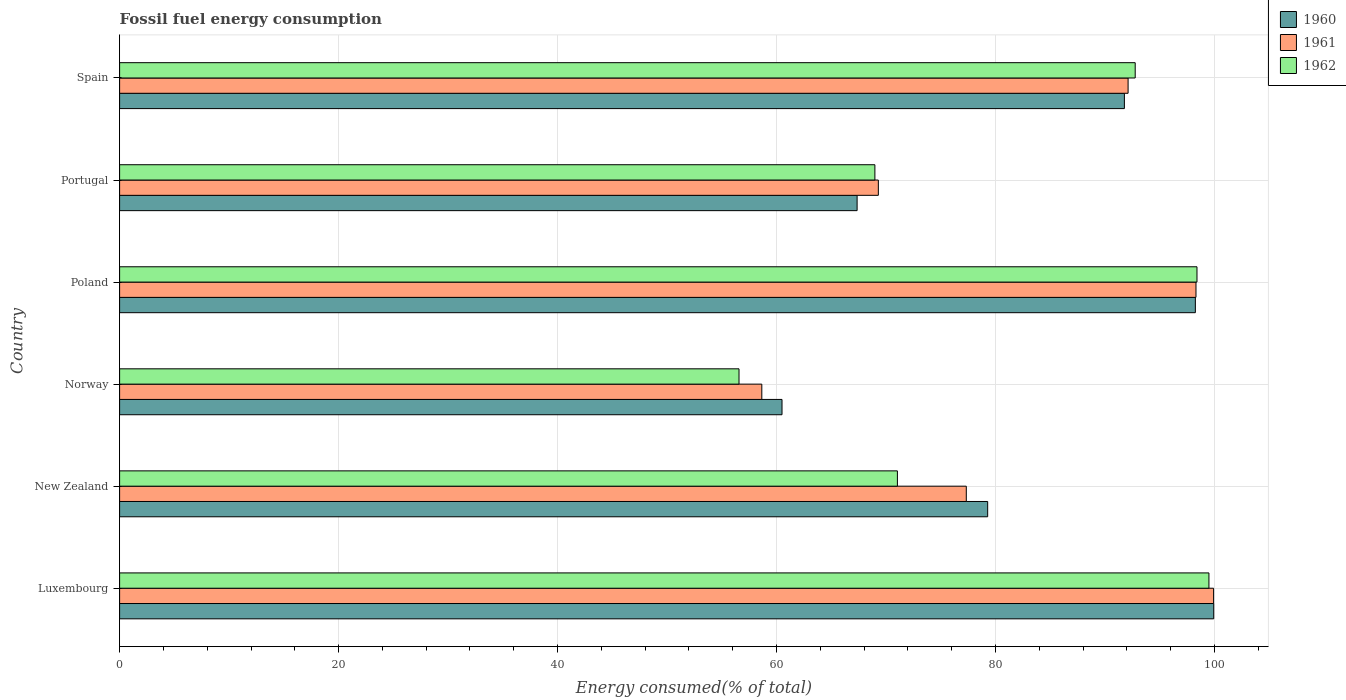How many groups of bars are there?
Give a very brief answer. 6. Are the number of bars per tick equal to the number of legend labels?
Your response must be concise. Yes. Are the number of bars on each tick of the Y-axis equal?
Give a very brief answer. Yes. How many bars are there on the 2nd tick from the top?
Your answer should be compact. 3. How many bars are there on the 3rd tick from the bottom?
Your response must be concise. 3. What is the label of the 6th group of bars from the top?
Offer a very short reply. Luxembourg. In how many cases, is the number of bars for a given country not equal to the number of legend labels?
Your response must be concise. 0. What is the percentage of energy consumed in 1962 in Poland?
Keep it short and to the point. 98.4. Across all countries, what is the maximum percentage of energy consumed in 1962?
Your answer should be compact. 99.49. Across all countries, what is the minimum percentage of energy consumed in 1961?
Your answer should be very brief. 58.65. In which country was the percentage of energy consumed in 1962 maximum?
Provide a short and direct response. Luxembourg. In which country was the percentage of energy consumed in 1962 minimum?
Offer a very short reply. Norway. What is the total percentage of energy consumed in 1961 in the graph?
Offer a very short reply. 495.6. What is the difference between the percentage of energy consumed in 1960 in Luxembourg and that in Poland?
Your answer should be compact. 1.68. What is the difference between the percentage of energy consumed in 1962 in Poland and the percentage of energy consumed in 1960 in New Zealand?
Give a very brief answer. 19.12. What is the average percentage of energy consumed in 1960 per country?
Your answer should be very brief. 82.84. What is the difference between the percentage of energy consumed in 1960 and percentage of energy consumed in 1961 in Norway?
Your answer should be very brief. 1.85. What is the ratio of the percentage of energy consumed in 1962 in New Zealand to that in Portugal?
Provide a succinct answer. 1.03. Is the percentage of energy consumed in 1961 in Luxembourg less than that in Spain?
Make the answer very short. No. What is the difference between the highest and the second highest percentage of energy consumed in 1961?
Offer a very short reply. 1.61. What is the difference between the highest and the lowest percentage of energy consumed in 1961?
Keep it short and to the point. 41.26. In how many countries, is the percentage of energy consumed in 1962 greater than the average percentage of energy consumed in 1962 taken over all countries?
Make the answer very short. 3. Is it the case that in every country, the sum of the percentage of energy consumed in 1962 and percentage of energy consumed in 1960 is greater than the percentage of energy consumed in 1961?
Keep it short and to the point. Yes. Are all the bars in the graph horizontal?
Give a very brief answer. Yes. How many countries are there in the graph?
Give a very brief answer. 6. Does the graph contain any zero values?
Make the answer very short. No. Does the graph contain grids?
Ensure brevity in your answer.  Yes. How many legend labels are there?
Your response must be concise. 3. How are the legend labels stacked?
Ensure brevity in your answer.  Vertical. What is the title of the graph?
Give a very brief answer. Fossil fuel energy consumption. What is the label or title of the X-axis?
Your answer should be compact. Energy consumed(% of total). What is the label or title of the Y-axis?
Your answer should be very brief. Country. What is the Energy consumed(% of total) of 1960 in Luxembourg?
Your answer should be compact. 99.92. What is the Energy consumed(% of total) in 1961 in Luxembourg?
Give a very brief answer. 99.91. What is the Energy consumed(% of total) of 1962 in Luxembourg?
Ensure brevity in your answer.  99.49. What is the Energy consumed(% of total) in 1960 in New Zealand?
Ensure brevity in your answer.  79.28. What is the Energy consumed(% of total) in 1961 in New Zealand?
Ensure brevity in your answer.  77.33. What is the Energy consumed(% of total) in 1962 in New Zealand?
Provide a short and direct response. 71.04. What is the Energy consumed(% of total) of 1960 in Norway?
Provide a succinct answer. 60.5. What is the Energy consumed(% of total) in 1961 in Norway?
Offer a very short reply. 58.65. What is the Energy consumed(% of total) of 1962 in Norway?
Make the answer very short. 56.57. What is the Energy consumed(% of total) in 1960 in Poland?
Your answer should be compact. 98.25. What is the Energy consumed(% of total) in 1961 in Poland?
Offer a terse response. 98.3. What is the Energy consumed(% of total) of 1962 in Poland?
Offer a very short reply. 98.4. What is the Energy consumed(% of total) in 1960 in Portugal?
Make the answer very short. 67.36. What is the Energy consumed(% of total) of 1961 in Portugal?
Offer a terse response. 69.3. What is the Energy consumed(% of total) in 1962 in Portugal?
Your answer should be compact. 68.98. What is the Energy consumed(% of total) in 1960 in Spain?
Provide a succinct answer. 91.77. What is the Energy consumed(% of total) in 1961 in Spain?
Make the answer very short. 92.1. What is the Energy consumed(% of total) in 1962 in Spain?
Give a very brief answer. 92.75. Across all countries, what is the maximum Energy consumed(% of total) in 1960?
Ensure brevity in your answer.  99.92. Across all countries, what is the maximum Energy consumed(% of total) in 1961?
Your answer should be very brief. 99.91. Across all countries, what is the maximum Energy consumed(% of total) of 1962?
Your answer should be very brief. 99.49. Across all countries, what is the minimum Energy consumed(% of total) of 1960?
Offer a very short reply. 60.5. Across all countries, what is the minimum Energy consumed(% of total) in 1961?
Offer a terse response. 58.65. Across all countries, what is the minimum Energy consumed(% of total) of 1962?
Offer a terse response. 56.57. What is the total Energy consumed(% of total) in 1960 in the graph?
Offer a terse response. 497.07. What is the total Energy consumed(% of total) of 1961 in the graph?
Provide a succinct answer. 495.6. What is the total Energy consumed(% of total) in 1962 in the graph?
Provide a succinct answer. 487.22. What is the difference between the Energy consumed(% of total) of 1960 in Luxembourg and that in New Zealand?
Your answer should be compact. 20.65. What is the difference between the Energy consumed(% of total) in 1961 in Luxembourg and that in New Zealand?
Make the answer very short. 22.58. What is the difference between the Energy consumed(% of total) of 1962 in Luxembourg and that in New Zealand?
Offer a very short reply. 28.45. What is the difference between the Energy consumed(% of total) in 1960 in Luxembourg and that in Norway?
Provide a succinct answer. 39.43. What is the difference between the Energy consumed(% of total) of 1961 in Luxembourg and that in Norway?
Provide a succinct answer. 41.26. What is the difference between the Energy consumed(% of total) in 1962 in Luxembourg and that in Norway?
Your response must be concise. 42.92. What is the difference between the Energy consumed(% of total) of 1960 in Luxembourg and that in Poland?
Keep it short and to the point. 1.68. What is the difference between the Energy consumed(% of total) of 1961 in Luxembourg and that in Poland?
Provide a short and direct response. 1.61. What is the difference between the Energy consumed(% of total) of 1962 in Luxembourg and that in Poland?
Give a very brief answer. 1.09. What is the difference between the Energy consumed(% of total) of 1960 in Luxembourg and that in Portugal?
Provide a short and direct response. 32.57. What is the difference between the Energy consumed(% of total) in 1961 in Luxembourg and that in Portugal?
Ensure brevity in your answer.  30.62. What is the difference between the Energy consumed(% of total) of 1962 in Luxembourg and that in Portugal?
Offer a very short reply. 30.51. What is the difference between the Energy consumed(% of total) of 1960 in Luxembourg and that in Spain?
Provide a short and direct response. 8.16. What is the difference between the Energy consumed(% of total) of 1961 in Luxembourg and that in Spain?
Your answer should be very brief. 7.81. What is the difference between the Energy consumed(% of total) of 1962 in Luxembourg and that in Spain?
Provide a succinct answer. 6.73. What is the difference between the Energy consumed(% of total) of 1960 in New Zealand and that in Norway?
Make the answer very short. 18.78. What is the difference between the Energy consumed(% of total) in 1961 in New Zealand and that in Norway?
Give a very brief answer. 18.68. What is the difference between the Energy consumed(% of total) of 1962 in New Zealand and that in Norway?
Make the answer very short. 14.47. What is the difference between the Energy consumed(% of total) in 1960 in New Zealand and that in Poland?
Make the answer very short. -18.97. What is the difference between the Energy consumed(% of total) in 1961 in New Zealand and that in Poland?
Offer a very short reply. -20.98. What is the difference between the Energy consumed(% of total) of 1962 in New Zealand and that in Poland?
Your response must be concise. -27.36. What is the difference between the Energy consumed(% of total) in 1960 in New Zealand and that in Portugal?
Offer a very short reply. 11.92. What is the difference between the Energy consumed(% of total) in 1961 in New Zealand and that in Portugal?
Your answer should be compact. 8.03. What is the difference between the Energy consumed(% of total) in 1962 in New Zealand and that in Portugal?
Ensure brevity in your answer.  2.06. What is the difference between the Energy consumed(% of total) of 1960 in New Zealand and that in Spain?
Offer a very short reply. -12.49. What is the difference between the Energy consumed(% of total) in 1961 in New Zealand and that in Spain?
Give a very brief answer. -14.78. What is the difference between the Energy consumed(% of total) of 1962 in New Zealand and that in Spain?
Provide a short and direct response. -21.72. What is the difference between the Energy consumed(% of total) of 1960 in Norway and that in Poland?
Your answer should be compact. -37.75. What is the difference between the Energy consumed(% of total) of 1961 in Norway and that in Poland?
Your response must be concise. -39.65. What is the difference between the Energy consumed(% of total) in 1962 in Norway and that in Poland?
Your response must be concise. -41.83. What is the difference between the Energy consumed(% of total) in 1960 in Norway and that in Portugal?
Provide a short and direct response. -6.86. What is the difference between the Energy consumed(% of total) of 1961 in Norway and that in Portugal?
Your response must be concise. -10.64. What is the difference between the Energy consumed(% of total) of 1962 in Norway and that in Portugal?
Your answer should be compact. -12.41. What is the difference between the Energy consumed(% of total) of 1960 in Norway and that in Spain?
Keep it short and to the point. -31.27. What is the difference between the Energy consumed(% of total) of 1961 in Norway and that in Spain?
Ensure brevity in your answer.  -33.45. What is the difference between the Energy consumed(% of total) in 1962 in Norway and that in Spain?
Your answer should be very brief. -36.18. What is the difference between the Energy consumed(% of total) of 1960 in Poland and that in Portugal?
Your answer should be compact. 30.89. What is the difference between the Energy consumed(% of total) in 1961 in Poland and that in Portugal?
Give a very brief answer. 29.01. What is the difference between the Energy consumed(% of total) in 1962 in Poland and that in Portugal?
Give a very brief answer. 29.42. What is the difference between the Energy consumed(% of total) in 1960 in Poland and that in Spain?
Your response must be concise. 6.48. What is the difference between the Energy consumed(% of total) of 1961 in Poland and that in Spain?
Provide a succinct answer. 6.2. What is the difference between the Energy consumed(% of total) in 1962 in Poland and that in Spain?
Ensure brevity in your answer.  5.64. What is the difference between the Energy consumed(% of total) of 1960 in Portugal and that in Spain?
Give a very brief answer. -24.41. What is the difference between the Energy consumed(% of total) of 1961 in Portugal and that in Spain?
Make the answer very short. -22.81. What is the difference between the Energy consumed(% of total) in 1962 in Portugal and that in Spain?
Offer a terse response. -23.77. What is the difference between the Energy consumed(% of total) in 1960 in Luxembourg and the Energy consumed(% of total) in 1961 in New Zealand?
Keep it short and to the point. 22.6. What is the difference between the Energy consumed(% of total) of 1960 in Luxembourg and the Energy consumed(% of total) of 1962 in New Zealand?
Your answer should be very brief. 28.89. What is the difference between the Energy consumed(% of total) in 1961 in Luxembourg and the Energy consumed(% of total) in 1962 in New Zealand?
Provide a short and direct response. 28.88. What is the difference between the Energy consumed(% of total) of 1960 in Luxembourg and the Energy consumed(% of total) of 1961 in Norway?
Your response must be concise. 41.27. What is the difference between the Energy consumed(% of total) of 1960 in Luxembourg and the Energy consumed(% of total) of 1962 in Norway?
Give a very brief answer. 43.35. What is the difference between the Energy consumed(% of total) of 1961 in Luxembourg and the Energy consumed(% of total) of 1962 in Norway?
Your answer should be very brief. 43.34. What is the difference between the Energy consumed(% of total) in 1960 in Luxembourg and the Energy consumed(% of total) in 1961 in Poland?
Offer a terse response. 1.62. What is the difference between the Energy consumed(% of total) in 1960 in Luxembourg and the Energy consumed(% of total) in 1962 in Poland?
Make the answer very short. 1.53. What is the difference between the Energy consumed(% of total) in 1961 in Luxembourg and the Energy consumed(% of total) in 1962 in Poland?
Make the answer very short. 1.52. What is the difference between the Energy consumed(% of total) in 1960 in Luxembourg and the Energy consumed(% of total) in 1961 in Portugal?
Provide a succinct answer. 30.63. What is the difference between the Energy consumed(% of total) of 1960 in Luxembourg and the Energy consumed(% of total) of 1962 in Portugal?
Offer a very short reply. 30.95. What is the difference between the Energy consumed(% of total) in 1961 in Luxembourg and the Energy consumed(% of total) in 1962 in Portugal?
Offer a terse response. 30.93. What is the difference between the Energy consumed(% of total) in 1960 in Luxembourg and the Energy consumed(% of total) in 1961 in Spain?
Keep it short and to the point. 7.82. What is the difference between the Energy consumed(% of total) in 1960 in Luxembourg and the Energy consumed(% of total) in 1962 in Spain?
Make the answer very short. 7.17. What is the difference between the Energy consumed(% of total) of 1961 in Luxembourg and the Energy consumed(% of total) of 1962 in Spain?
Provide a succinct answer. 7.16. What is the difference between the Energy consumed(% of total) of 1960 in New Zealand and the Energy consumed(% of total) of 1961 in Norway?
Provide a succinct answer. 20.63. What is the difference between the Energy consumed(% of total) of 1960 in New Zealand and the Energy consumed(% of total) of 1962 in Norway?
Your response must be concise. 22.71. What is the difference between the Energy consumed(% of total) in 1961 in New Zealand and the Energy consumed(% of total) in 1962 in Norway?
Keep it short and to the point. 20.76. What is the difference between the Energy consumed(% of total) in 1960 in New Zealand and the Energy consumed(% of total) in 1961 in Poland?
Your response must be concise. -19.02. What is the difference between the Energy consumed(% of total) of 1960 in New Zealand and the Energy consumed(% of total) of 1962 in Poland?
Offer a very short reply. -19.12. What is the difference between the Energy consumed(% of total) of 1961 in New Zealand and the Energy consumed(% of total) of 1962 in Poland?
Keep it short and to the point. -21.07. What is the difference between the Energy consumed(% of total) in 1960 in New Zealand and the Energy consumed(% of total) in 1961 in Portugal?
Offer a very short reply. 9.98. What is the difference between the Energy consumed(% of total) in 1960 in New Zealand and the Energy consumed(% of total) in 1962 in Portugal?
Provide a short and direct response. 10.3. What is the difference between the Energy consumed(% of total) of 1961 in New Zealand and the Energy consumed(% of total) of 1962 in Portugal?
Your answer should be very brief. 8.35. What is the difference between the Energy consumed(% of total) of 1960 in New Zealand and the Energy consumed(% of total) of 1961 in Spain?
Give a very brief answer. -12.83. What is the difference between the Energy consumed(% of total) in 1960 in New Zealand and the Energy consumed(% of total) in 1962 in Spain?
Offer a very short reply. -13.47. What is the difference between the Energy consumed(% of total) of 1961 in New Zealand and the Energy consumed(% of total) of 1962 in Spain?
Provide a succinct answer. -15.43. What is the difference between the Energy consumed(% of total) in 1960 in Norway and the Energy consumed(% of total) in 1961 in Poland?
Ensure brevity in your answer.  -37.81. What is the difference between the Energy consumed(% of total) in 1960 in Norway and the Energy consumed(% of total) in 1962 in Poland?
Provide a short and direct response. -37.9. What is the difference between the Energy consumed(% of total) in 1961 in Norway and the Energy consumed(% of total) in 1962 in Poland?
Offer a terse response. -39.74. What is the difference between the Energy consumed(% of total) in 1960 in Norway and the Energy consumed(% of total) in 1961 in Portugal?
Provide a succinct answer. -8.8. What is the difference between the Energy consumed(% of total) in 1960 in Norway and the Energy consumed(% of total) in 1962 in Portugal?
Make the answer very short. -8.48. What is the difference between the Energy consumed(% of total) of 1961 in Norway and the Energy consumed(% of total) of 1962 in Portugal?
Offer a terse response. -10.33. What is the difference between the Energy consumed(% of total) of 1960 in Norway and the Energy consumed(% of total) of 1961 in Spain?
Provide a succinct answer. -31.61. What is the difference between the Energy consumed(% of total) in 1960 in Norway and the Energy consumed(% of total) in 1962 in Spain?
Make the answer very short. -32.26. What is the difference between the Energy consumed(% of total) of 1961 in Norway and the Energy consumed(% of total) of 1962 in Spain?
Keep it short and to the point. -34.1. What is the difference between the Energy consumed(% of total) of 1960 in Poland and the Energy consumed(% of total) of 1961 in Portugal?
Keep it short and to the point. 28.95. What is the difference between the Energy consumed(% of total) in 1960 in Poland and the Energy consumed(% of total) in 1962 in Portugal?
Give a very brief answer. 29.27. What is the difference between the Energy consumed(% of total) in 1961 in Poland and the Energy consumed(% of total) in 1962 in Portugal?
Give a very brief answer. 29.32. What is the difference between the Energy consumed(% of total) in 1960 in Poland and the Energy consumed(% of total) in 1961 in Spain?
Provide a short and direct response. 6.14. What is the difference between the Energy consumed(% of total) in 1960 in Poland and the Energy consumed(% of total) in 1962 in Spain?
Keep it short and to the point. 5.49. What is the difference between the Energy consumed(% of total) in 1961 in Poland and the Energy consumed(% of total) in 1962 in Spain?
Give a very brief answer. 5.55. What is the difference between the Energy consumed(% of total) in 1960 in Portugal and the Energy consumed(% of total) in 1961 in Spain?
Your answer should be compact. -24.75. What is the difference between the Energy consumed(% of total) of 1960 in Portugal and the Energy consumed(% of total) of 1962 in Spain?
Your answer should be compact. -25.4. What is the difference between the Energy consumed(% of total) in 1961 in Portugal and the Energy consumed(% of total) in 1962 in Spain?
Offer a very short reply. -23.46. What is the average Energy consumed(% of total) of 1960 per country?
Ensure brevity in your answer.  82.84. What is the average Energy consumed(% of total) of 1961 per country?
Provide a succinct answer. 82.6. What is the average Energy consumed(% of total) of 1962 per country?
Offer a terse response. 81.2. What is the difference between the Energy consumed(% of total) of 1960 and Energy consumed(% of total) of 1961 in Luxembourg?
Offer a very short reply. 0.01. What is the difference between the Energy consumed(% of total) of 1960 and Energy consumed(% of total) of 1962 in Luxembourg?
Your answer should be compact. 0.44. What is the difference between the Energy consumed(% of total) in 1961 and Energy consumed(% of total) in 1962 in Luxembourg?
Your response must be concise. 0.42. What is the difference between the Energy consumed(% of total) in 1960 and Energy consumed(% of total) in 1961 in New Zealand?
Offer a terse response. 1.95. What is the difference between the Energy consumed(% of total) of 1960 and Energy consumed(% of total) of 1962 in New Zealand?
Give a very brief answer. 8.24. What is the difference between the Energy consumed(% of total) of 1961 and Energy consumed(% of total) of 1962 in New Zealand?
Ensure brevity in your answer.  6.29. What is the difference between the Energy consumed(% of total) in 1960 and Energy consumed(% of total) in 1961 in Norway?
Make the answer very short. 1.85. What is the difference between the Energy consumed(% of total) in 1960 and Energy consumed(% of total) in 1962 in Norway?
Your answer should be very brief. 3.93. What is the difference between the Energy consumed(% of total) of 1961 and Energy consumed(% of total) of 1962 in Norway?
Provide a succinct answer. 2.08. What is the difference between the Energy consumed(% of total) in 1960 and Energy consumed(% of total) in 1961 in Poland?
Give a very brief answer. -0.06. What is the difference between the Energy consumed(% of total) in 1960 and Energy consumed(% of total) in 1962 in Poland?
Your answer should be very brief. -0.15. What is the difference between the Energy consumed(% of total) in 1961 and Energy consumed(% of total) in 1962 in Poland?
Ensure brevity in your answer.  -0.09. What is the difference between the Energy consumed(% of total) in 1960 and Energy consumed(% of total) in 1961 in Portugal?
Keep it short and to the point. -1.94. What is the difference between the Energy consumed(% of total) in 1960 and Energy consumed(% of total) in 1962 in Portugal?
Your answer should be compact. -1.62. What is the difference between the Energy consumed(% of total) in 1961 and Energy consumed(% of total) in 1962 in Portugal?
Keep it short and to the point. 0.32. What is the difference between the Energy consumed(% of total) in 1960 and Energy consumed(% of total) in 1961 in Spain?
Make the answer very short. -0.34. What is the difference between the Energy consumed(% of total) in 1960 and Energy consumed(% of total) in 1962 in Spain?
Keep it short and to the point. -0.99. What is the difference between the Energy consumed(% of total) in 1961 and Energy consumed(% of total) in 1962 in Spain?
Make the answer very short. -0.65. What is the ratio of the Energy consumed(% of total) in 1960 in Luxembourg to that in New Zealand?
Make the answer very short. 1.26. What is the ratio of the Energy consumed(% of total) of 1961 in Luxembourg to that in New Zealand?
Ensure brevity in your answer.  1.29. What is the ratio of the Energy consumed(% of total) in 1962 in Luxembourg to that in New Zealand?
Give a very brief answer. 1.4. What is the ratio of the Energy consumed(% of total) in 1960 in Luxembourg to that in Norway?
Your response must be concise. 1.65. What is the ratio of the Energy consumed(% of total) of 1961 in Luxembourg to that in Norway?
Ensure brevity in your answer.  1.7. What is the ratio of the Energy consumed(% of total) in 1962 in Luxembourg to that in Norway?
Your answer should be very brief. 1.76. What is the ratio of the Energy consumed(% of total) of 1960 in Luxembourg to that in Poland?
Keep it short and to the point. 1.02. What is the ratio of the Energy consumed(% of total) in 1961 in Luxembourg to that in Poland?
Offer a terse response. 1.02. What is the ratio of the Energy consumed(% of total) in 1962 in Luxembourg to that in Poland?
Offer a terse response. 1.01. What is the ratio of the Energy consumed(% of total) in 1960 in Luxembourg to that in Portugal?
Your answer should be very brief. 1.48. What is the ratio of the Energy consumed(% of total) in 1961 in Luxembourg to that in Portugal?
Your answer should be very brief. 1.44. What is the ratio of the Energy consumed(% of total) of 1962 in Luxembourg to that in Portugal?
Your answer should be compact. 1.44. What is the ratio of the Energy consumed(% of total) in 1960 in Luxembourg to that in Spain?
Your answer should be very brief. 1.09. What is the ratio of the Energy consumed(% of total) of 1961 in Luxembourg to that in Spain?
Ensure brevity in your answer.  1.08. What is the ratio of the Energy consumed(% of total) in 1962 in Luxembourg to that in Spain?
Ensure brevity in your answer.  1.07. What is the ratio of the Energy consumed(% of total) in 1960 in New Zealand to that in Norway?
Offer a very short reply. 1.31. What is the ratio of the Energy consumed(% of total) of 1961 in New Zealand to that in Norway?
Give a very brief answer. 1.32. What is the ratio of the Energy consumed(% of total) of 1962 in New Zealand to that in Norway?
Give a very brief answer. 1.26. What is the ratio of the Energy consumed(% of total) in 1960 in New Zealand to that in Poland?
Your answer should be compact. 0.81. What is the ratio of the Energy consumed(% of total) of 1961 in New Zealand to that in Poland?
Your response must be concise. 0.79. What is the ratio of the Energy consumed(% of total) of 1962 in New Zealand to that in Poland?
Your answer should be very brief. 0.72. What is the ratio of the Energy consumed(% of total) of 1960 in New Zealand to that in Portugal?
Offer a terse response. 1.18. What is the ratio of the Energy consumed(% of total) in 1961 in New Zealand to that in Portugal?
Ensure brevity in your answer.  1.12. What is the ratio of the Energy consumed(% of total) of 1962 in New Zealand to that in Portugal?
Your answer should be compact. 1.03. What is the ratio of the Energy consumed(% of total) of 1960 in New Zealand to that in Spain?
Provide a succinct answer. 0.86. What is the ratio of the Energy consumed(% of total) in 1961 in New Zealand to that in Spain?
Your answer should be compact. 0.84. What is the ratio of the Energy consumed(% of total) in 1962 in New Zealand to that in Spain?
Your response must be concise. 0.77. What is the ratio of the Energy consumed(% of total) in 1960 in Norway to that in Poland?
Keep it short and to the point. 0.62. What is the ratio of the Energy consumed(% of total) in 1961 in Norway to that in Poland?
Keep it short and to the point. 0.6. What is the ratio of the Energy consumed(% of total) of 1962 in Norway to that in Poland?
Make the answer very short. 0.57. What is the ratio of the Energy consumed(% of total) in 1960 in Norway to that in Portugal?
Your answer should be compact. 0.9. What is the ratio of the Energy consumed(% of total) of 1961 in Norway to that in Portugal?
Keep it short and to the point. 0.85. What is the ratio of the Energy consumed(% of total) in 1962 in Norway to that in Portugal?
Offer a terse response. 0.82. What is the ratio of the Energy consumed(% of total) of 1960 in Norway to that in Spain?
Provide a short and direct response. 0.66. What is the ratio of the Energy consumed(% of total) in 1961 in Norway to that in Spain?
Make the answer very short. 0.64. What is the ratio of the Energy consumed(% of total) of 1962 in Norway to that in Spain?
Your answer should be very brief. 0.61. What is the ratio of the Energy consumed(% of total) in 1960 in Poland to that in Portugal?
Keep it short and to the point. 1.46. What is the ratio of the Energy consumed(% of total) in 1961 in Poland to that in Portugal?
Offer a terse response. 1.42. What is the ratio of the Energy consumed(% of total) in 1962 in Poland to that in Portugal?
Keep it short and to the point. 1.43. What is the ratio of the Energy consumed(% of total) of 1960 in Poland to that in Spain?
Provide a succinct answer. 1.07. What is the ratio of the Energy consumed(% of total) in 1961 in Poland to that in Spain?
Make the answer very short. 1.07. What is the ratio of the Energy consumed(% of total) in 1962 in Poland to that in Spain?
Keep it short and to the point. 1.06. What is the ratio of the Energy consumed(% of total) in 1960 in Portugal to that in Spain?
Provide a succinct answer. 0.73. What is the ratio of the Energy consumed(% of total) in 1961 in Portugal to that in Spain?
Make the answer very short. 0.75. What is the ratio of the Energy consumed(% of total) of 1962 in Portugal to that in Spain?
Ensure brevity in your answer.  0.74. What is the difference between the highest and the second highest Energy consumed(% of total) of 1960?
Keep it short and to the point. 1.68. What is the difference between the highest and the second highest Energy consumed(% of total) of 1961?
Offer a terse response. 1.61. What is the difference between the highest and the second highest Energy consumed(% of total) in 1962?
Keep it short and to the point. 1.09. What is the difference between the highest and the lowest Energy consumed(% of total) of 1960?
Offer a terse response. 39.43. What is the difference between the highest and the lowest Energy consumed(% of total) of 1961?
Give a very brief answer. 41.26. What is the difference between the highest and the lowest Energy consumed(% of total) of 1962?
Give a very brief answer. 42.92. 